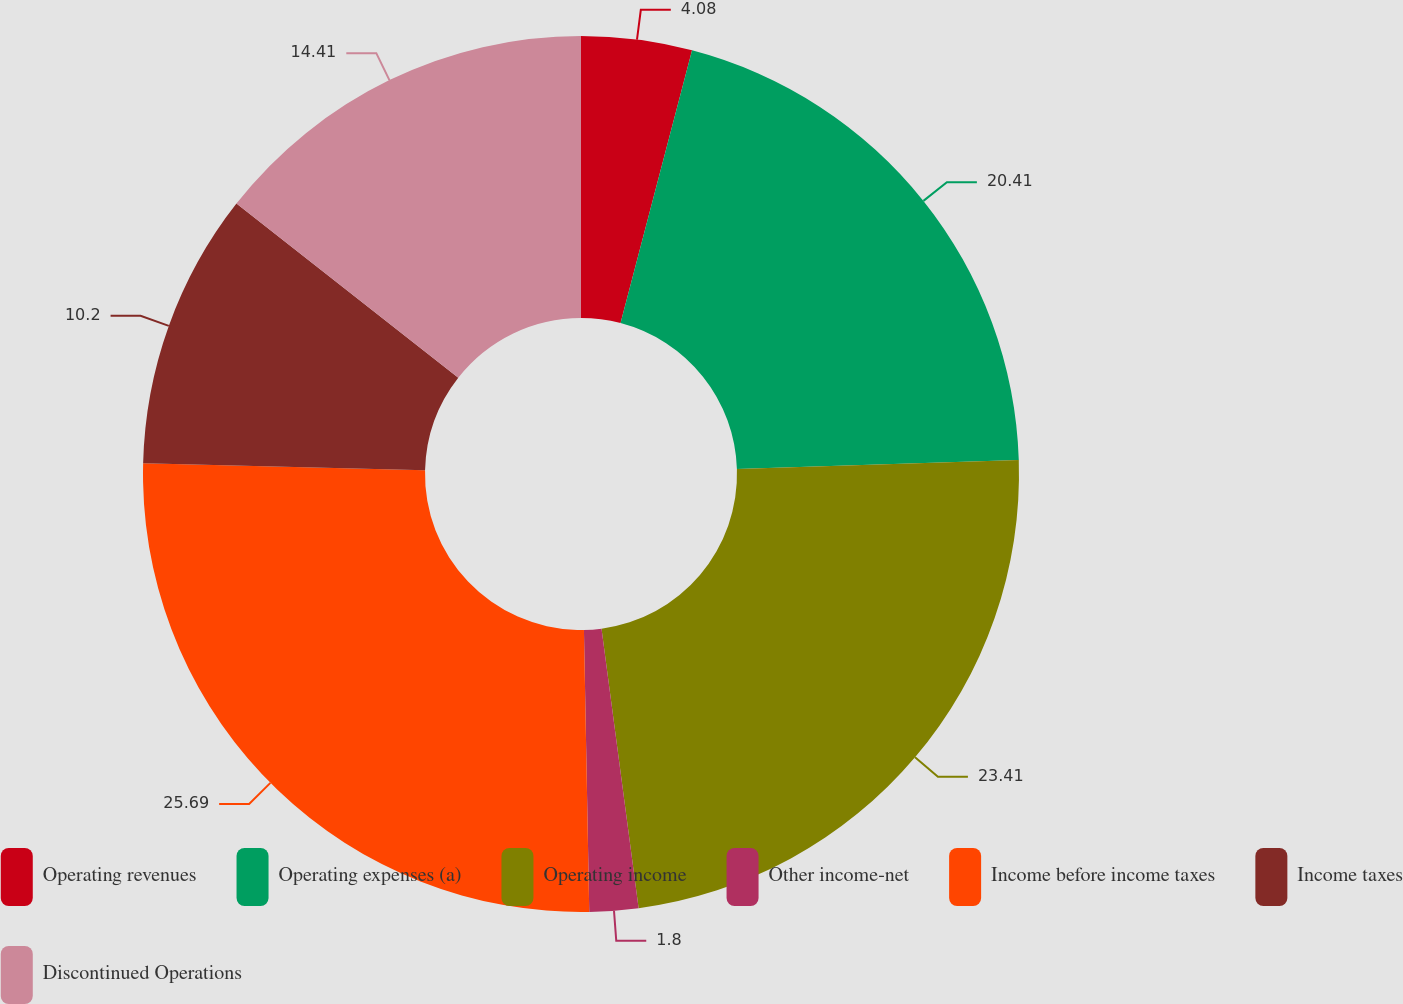Convert chart to OTSL. <chart><loc_0><loc_0><loc_500><loc_500><pie_chart><fcel>Operating revenues<fcel>Operating expenses (a)<fcel>Operating income<fcel>Other income-net<fcel>Income before income taxes<fcel>Income taxes<fcel>Discontinued Operations<nl><fcel>4.08%<fcel>20.41%<fcel>23.41%<fcel>1.8%<fcel>25.69%<fcel>10.2%<fcel>14.41%<nl></chart> 